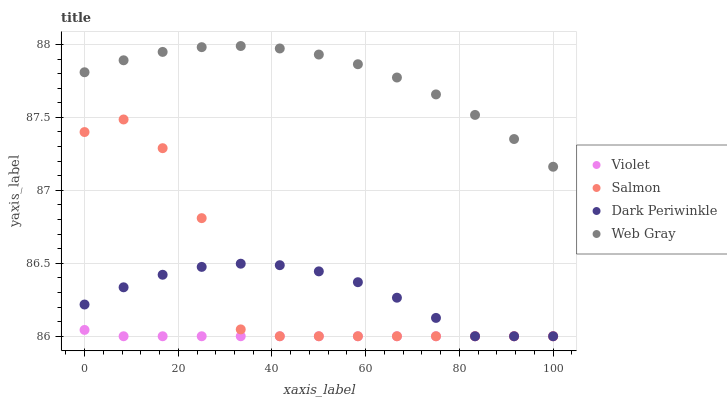Does Violet have the minimum area under the curve?
Answer yes or no. Yes. Does Web Gray have the maximum area under the curve?
Answer yes or no. Yes. Does Salmon have the minimum area under the curve?
Answer yes or no. No. Does Salmon have the maximum area under the curve?
Answer yes or no. No. Is Violet the smoothest?
Answer yes or no. Yes. Is Salmon the roughest?
Answer yes or no. Yes. Is Dark Periwinkle the smoothest?
Answer yes or no. No. Is Dark Periwinkle the roughest?
Answer yes or no. No. Does Salmon have the lowest value?
Answer yes or no. Yes. Does Web Gray have the highest value?
Answer yes or no. Yes. Does Salmon have the highest value?
Answer yes or no. No. Is Salmon less than Web Gray?
Answer yes or no. Yes. Is Web Gray greater than Violet?
Answer yes or no. Yes. Does Violet intersect Salmon?
Answer yes or no. Yes. Is Violet less than Salmon?
Answer yes or no. No. Is Violet greater than Salmon?
Answer yes or no. No. Does Salmon intersect Web Gray?
Answer yes or no. No. 